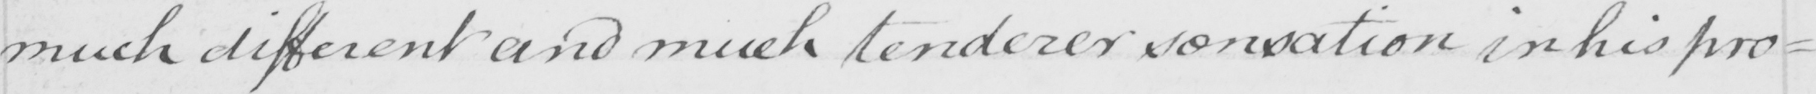What is written in this line of handwriting? much different and much tenderer sensation in his pro= 